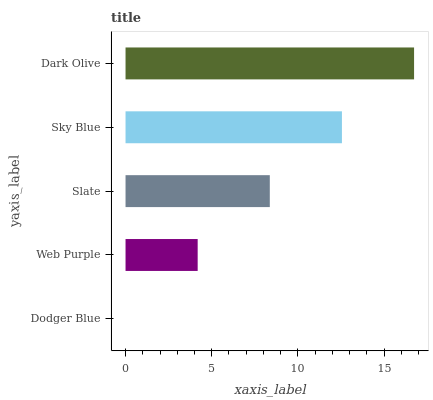Is Dodger Blue the minimum?
Answer yes or no. Yes. Is Dark Olive the maximum?
Answer yes or no. Yes. Is Web Purple the minimum?
Answer yes or no. No. Is Web Purple the maximum?
Answer yes or no. No. Is Web Purple greater than Dodger Blue?
Answer yes or no. Yes. Is Dodger Blue less than Web Purple?
Answer yes or no. Yes. Is Dodger Blue greater than Web Purple?
Answer yes or no. No. Is Web Purple less than Dodger Blue?
Answer yes or no. No. Is Slate the high median?
Answer yes or no. Yes. Is Slate the low median?
Answer yes or no. Yes. Is Web Purple the high median?
Answer yes or no. No. Is Dodger Blue the low median?
Answer yes or no. No. 